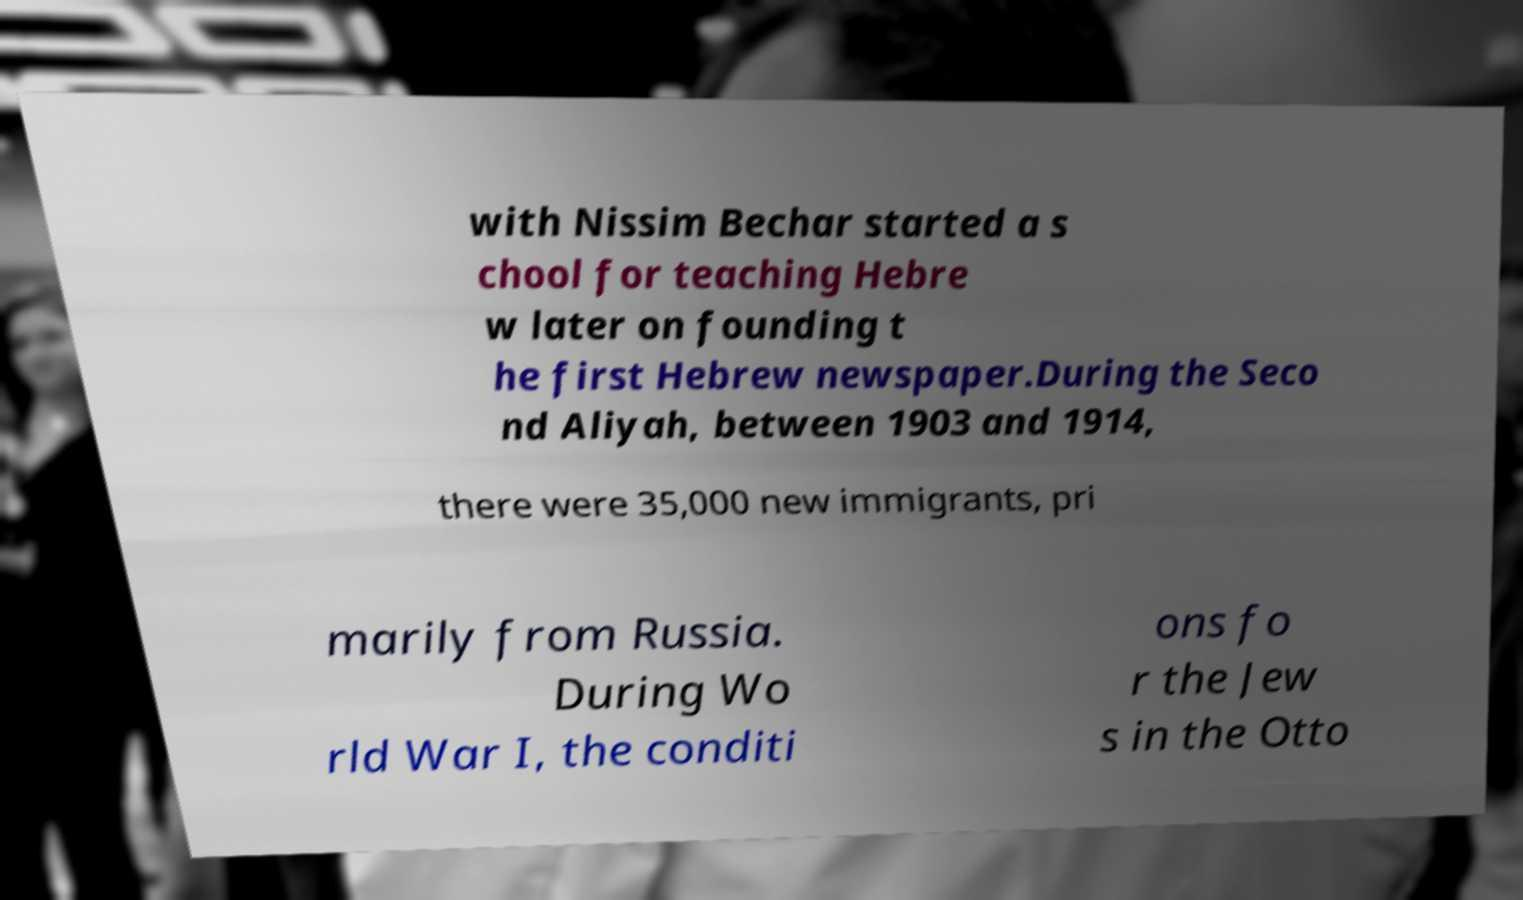Please read and relay the text visible in this image. What does it say? with Nissim Bechar started a s chool for teaching Hebre w later on founding t he first Hebrew newspaper.During the Seco nd Aliyah, between 1903 and 1914, there were 35,000 new immigrants, pri marily from Russia. During Wo rld War I, the conditi ons fo r the Jew s in the Otto 